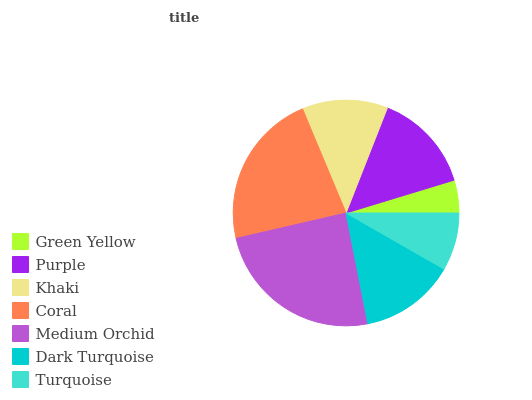Is Green Yellow the minimum?
Answer yes or no. Yes. Is Medium Orchid the maximum?
Answer yes or no. Yes. Is Purple the minimum?
Answer yes or no. No. Is Purple the maximum?
Answer yes or no. No. Is Purple greater than Green Yellow?
Answer yes or no. Yes. Is Green Yellow less than Purple?
Answer yes or no. Yes. Is Green Yellow greater than Purple?
Answer yes or no. No. Is Purple less than Green Yellow?
Answer yes or no. No. Is Dark Turquoise the high median?
Answer yes or no. Yes. Is Dark Turquoise the low median?
Answer yes or no. Yes. Is Medium Orchid the high median?
Answer yes or no. No. Is Medium Orchid the low median?
Answer yes or no. No. 